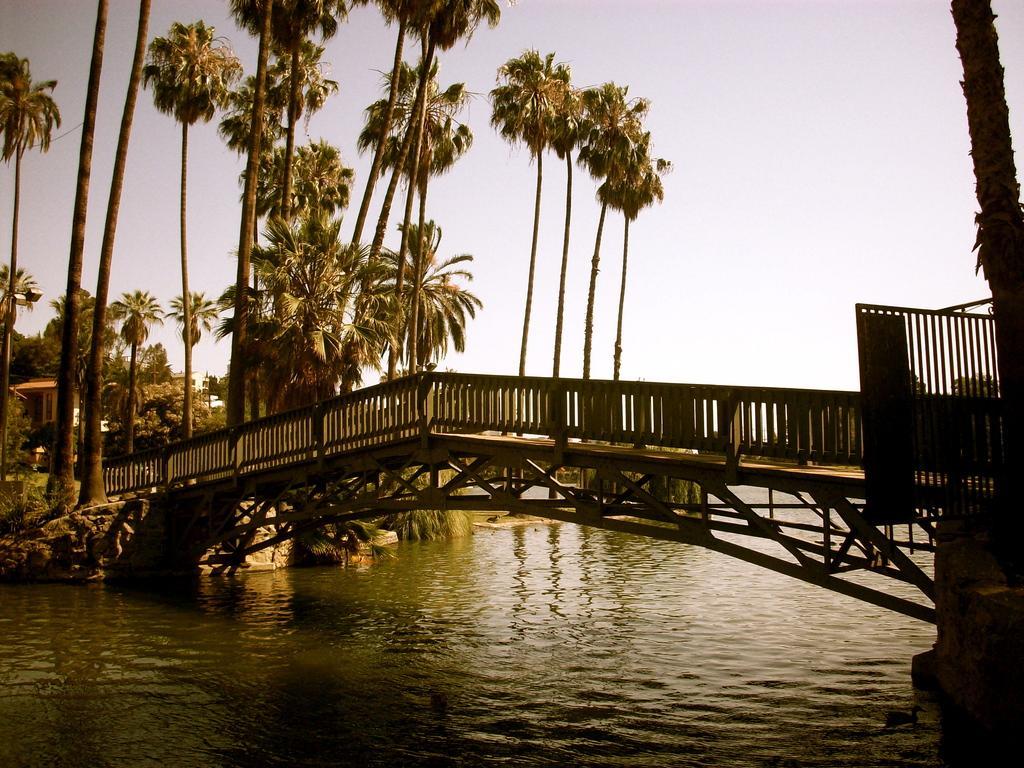Can you describe this image briefly? In this image I can see water in the front and over it I can see a bridge. In the background I can see number of trees, a building and the sky. 